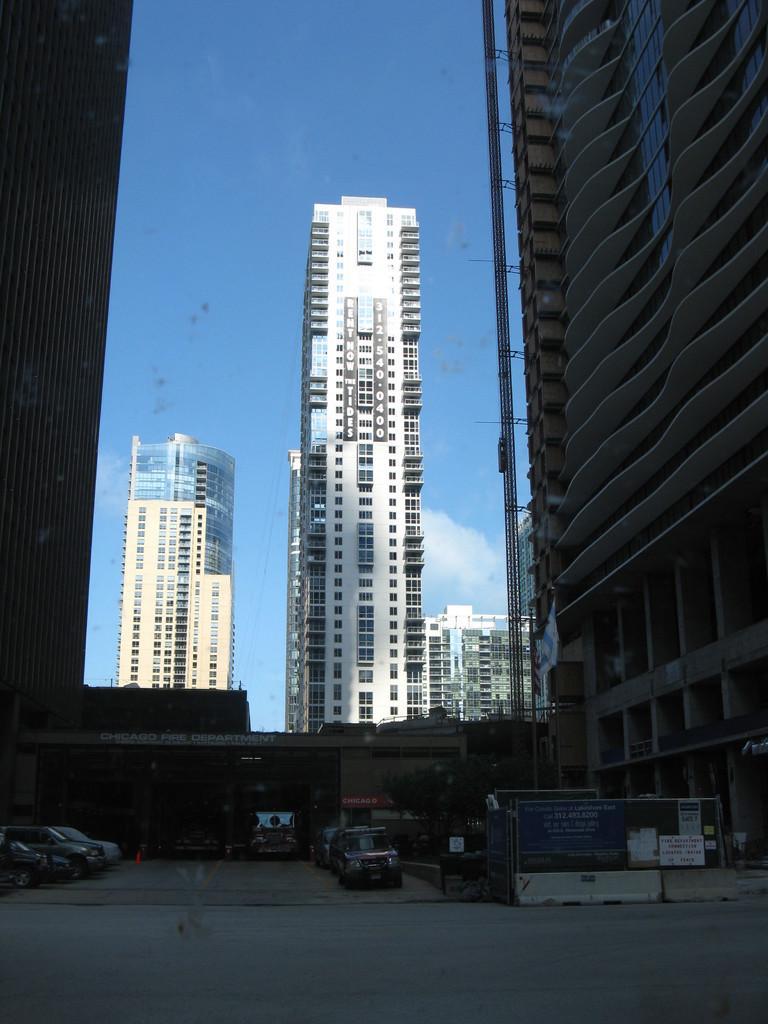Describe this image in one or two sentences. This picture is clicked outside the city. Here, we see many buildings in this picture. At the bottom of the picture, there are many cars parked on the road and beside that, we see an iron fence. At the top of the picture, we see the sky, which is in blue color. 